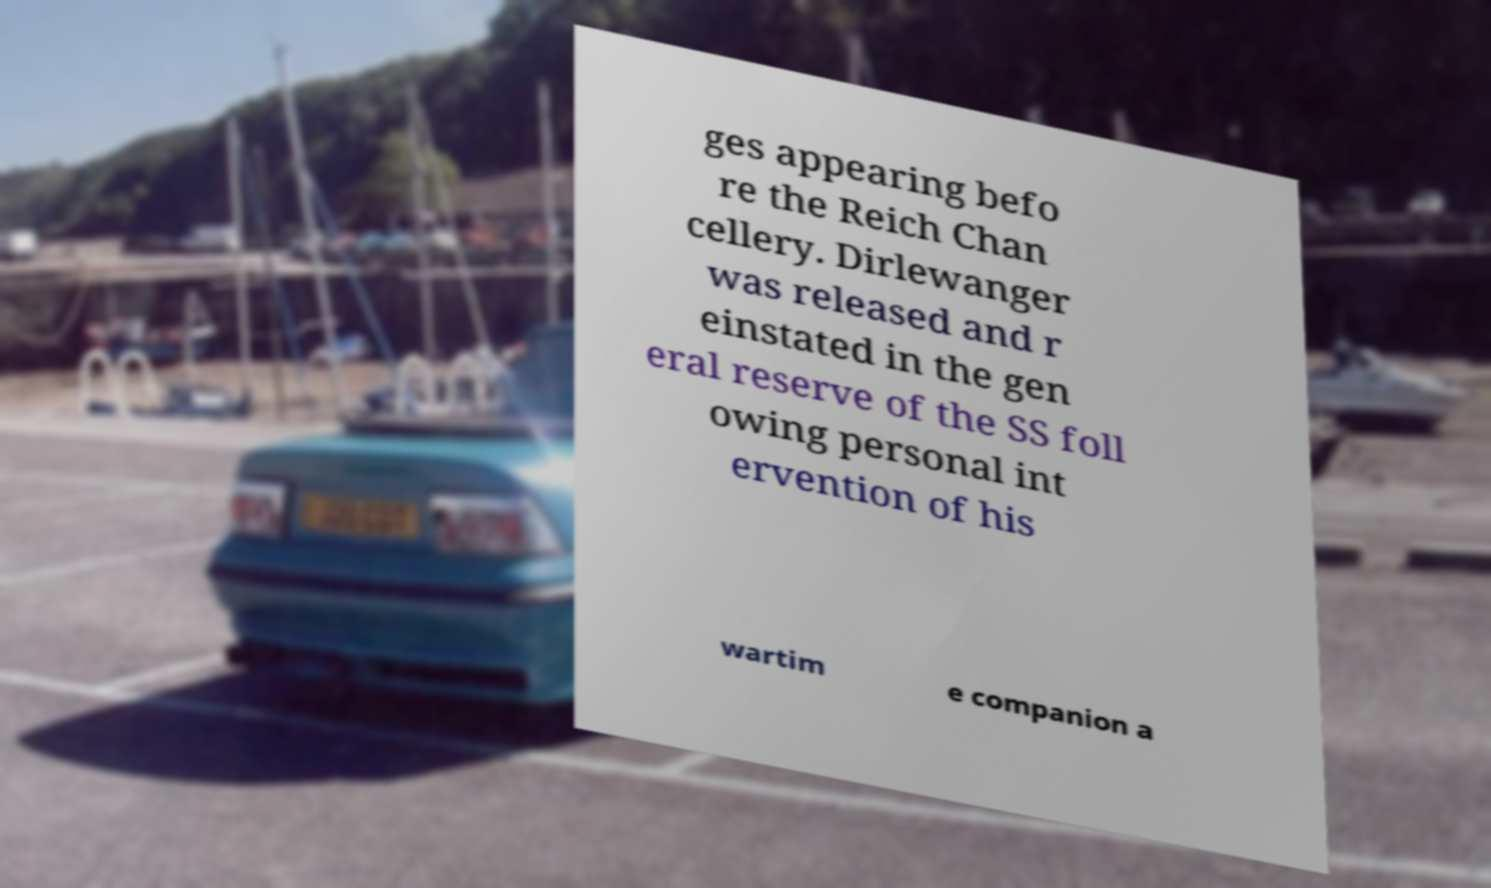Could you assist in decoding the text presented in this image and type it out clearly? ges appearing befo re the Reich Chan cellery. Dirlewanger was released and r einstated in the gen eral reserve of the SS foll owing personal int ervention of his wartim e companion a 